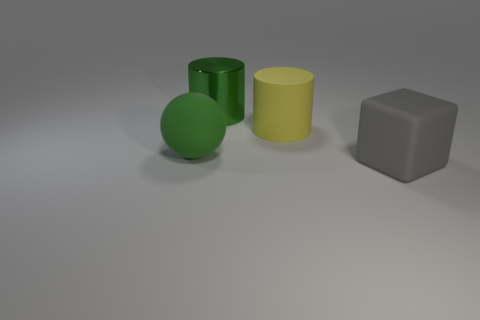Does the large rubber thing that is to the left of the green shiny cylinder have the same color as the big shiny cylinder?
Keep it short and to the point. Yes. There is a large object that is in front of the big matte object that is left of the big cylinder behind the big matte cylinder; what is its color?
Provide a short and direct response. Gray. Are the large gray cube and the big green ball made of the same material?
Ensure brevity in your answer.  Yes. There is a thing on the left side of the green object that is behind the green rubber thing; is there a large gray matte object that is right of it?
Your answer should be very brief. Yes. Do the large rubber sphere and the large metal cylinder have the same color?
Offer a very short reply. Yes. Are there fewer big green objects than large metal cylinders?
Your answer should be very brief. No. Are the large object that is in front of the large rubber ball and the big cylinder on the left side of the large yellow matte thing made of the same material?
Provide a short and direct response. No. Is the number of big yellow matte objects right of the large rubber cylinder less than the number of yellow things?
Your answer should be very brief. Yes. How many objects are behind the large green object on the left side of the large green cylinder?
Ensure brevity in your answer.  2. Are there any other things that have the same material as the green cylinder?
Your response must be concise. No. 